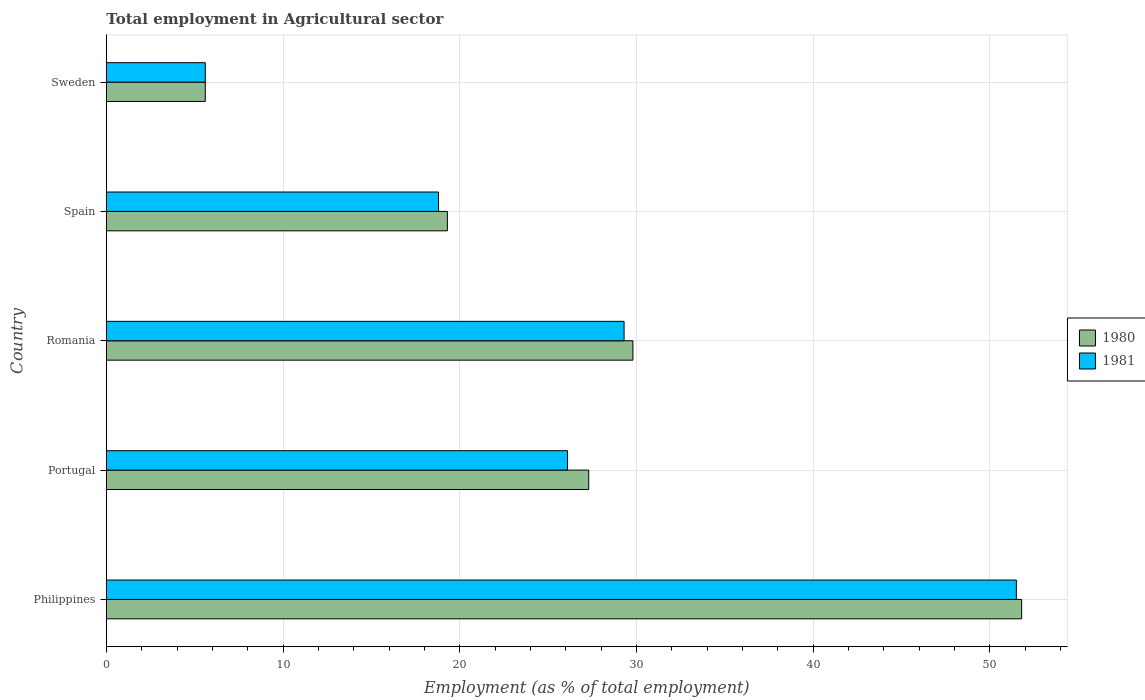Are the number of bars per tick equal to the number of legend labels?
Give a very brief answer. Yes. Are the number of bars on each tick of the Y-axis equal?
Provide a short and direct response. Yes. How many bars are there on the 4th tick from the top?
Ensure brevity in your answer.  2. What is the label of the 3rd group of bars from the top?
Give a very brief answer. Romania. In how many cases, is the number of bars for a given country not equal to the number of legend labels?
Your answer should be compact. 0. What is the employment in agricultural sector in 1980 in Sweden?
Your answer should be very brief. 5.6. Across all countries, what is the maximum employment in agricultural sector in 1981?
Give a very brief answer. 51.5. Across all countries, what is the minimum employment in agricultural sector in 1981?
Your answer should be very brief. 5.6. In which country was the employment in agricultural sector in 1981 maximum?
Provide a short and direct response. Philippines. In which country was the employment in agricultural sector in 1981 minimum?
Keep it short and to the point. Sweden. What is the total employment in agricultural sector in 1980 in the graph?
Ensure brevity in your answer.  133.8. What is the difference between the employment in agricultural sector in 1981 in Spain and that in Sweden?
Offer a very short reply. 13.2. What is the difference between the employment in agricultural sector in 1980 in Spain and the employment in agricultural sector in 1981 in Portugal?
Offer a very short reply. -6.8. What is the average employment in agricultural sector in 1981 per country?
Provide a succinct answer. 26.26. What is the difference between the employment in agricultural sector in 1980 and employment in agricultural sector in 1981 in Philippines?
Your answer should be compact. 0.3. In how many countries, is the employment in agricultural sector in 1981 greater than 34 %?
Ensure brevity in your answer.  1. What is the ratio of the employment in agricultural sector in 1980 in Philippines to that in Sweden?
Ensure brevity in your answer.  9.25. What is the difference between the highest and the second highest employment in agricultural sector in 1980?
Offer a very short reply. 22. What is the difference between the highest and the lowest employment in agricultural sector in 1980?
Your answer should be compact. 46.2. Is the sum of the employment in agricultural sector in 1981 in Romania and Sweden greater than the maximum employment in agricultural sector in 1980 across all countries?
Offer a very short reply. No. How many bars are there?
Provide a short and direct response. 10. How many countries are there in the graph?
Make the answer very short. 5. Does the graph contain grids?
Give a very brief answer. Yes. How are the legend labels stacked?
Keep it short and to the point. Vertical. What is the title of the graph?
Offer a terse response. Total employment in Agricultural sector. What is the label or title of the X-axis?
Make the answer very short. Employment (as % of total employment). What is the label or title of the Y-axis?
Your response must be concise. Country. What is the Employment (as % of total employment) of 1980 in Philippines?
Keep it short and to the point. 51.8. What is the Employment (as % of total employment) of 1981 in Philippines?
Make the answer very short. 51.5. What is the Employment (as % of total employment) in 1980 in Portugal?
Give a very brief answer. 27.3. What is the Employment (as % of total employment) in 1981 in Portugal?
Your answer should be compact. 26.1. What is the Employment (as % of total employment) of 1980 in Romania?
Your answer should be compact. 29.8. What is the Employment (as % of total employment) of 1981 in Romania?
Ensure brevity in your answer.  29.3. What is the Employment (as % of total employment) of 1980 in Spain?
Provide a succinct answer. 19.3. What is the Employment (as % of total employment) in 1981 in Spain?
Ensure brevity in your answer.  18.8. What is the Employment (as % of total employment) of 1980 in Sweden?
Provide a short and direct response. 5.6. What is the Employment (as % of total employment) of 1981 in Sweden?
Provide a succinct answer. 5.6. Across all countries, what is the maximum Employment (as % of total employment) in 1980?
Make the answer very short. 51.8. Across all countries, what is the maximum Employment (as % of total employment) of 1981?
Your answer should be compact. 51.5. Across all countries, what is the minimum Employment (as % of total employment) of 1980?
Give a very brief answer. 5.6. Across all countries, what is the minimum Employment (as % of total employment) of 1981?
Provide a short and direct response. 5.6. What is the total Employment (as % of total employment) of 1980 in the graph?
Ensure brevity in your answer.  133.8. What is the total Employment (as % of total employment) of 1981 in the graph?
Offer a very short reply. 131.3. What is the difference between the Employment (as % of total employment) of 1980 in Philippines and that in Portugal?
Offer a very short reply. 24.5. What is the difference between the Employment (as % of total employment) in 1981 in Philippines and that in Portugal?
Your answer should be compact. 25.4. What is the difference between the Employment (as % of total employment) of 1980 in Philippines and that in Romania?
Make the answer very short. 22. What is the difference between the Employment (as % of total employment) in 1981 in Philippines and that in Romania?
Provide a succinct answer. 22.2. What is the difference between the Employment (as % of total employment) of 1980 in Philippines and that in Spain?
Make the answer very short. 32.5. What is the difference between the Employment (as % of total employment) of 1981 in Philippines and that in Spain?
Provide a short and direct response. 32.7. What is the difference between the Employment (as % of total employment) of 1980 in Philippines and that in Sweden?
Your response must be concise. 46.2. What is the difference between the Employment (as % of total employment) of 1981 in Philippines and that in Sweden?
Your answer should be compact. 45.9. What is the difference between the Employment (as % of total employment) of 1980 in Portugal and that in Romania?
Make the answer very short. -2.5. What is the difference between the Employment (as % of total employment) in 1980 in Portugal and that in Spain?
Your answer should be compact. 8. What is the difference between the Employment (as % of total employment) in 1980 in Portugal and that in Sweden?
Provide a succinct answer. 21.7. What is the difference between the Employment (as % of total employment) of 1981 in Portugal and that in Sweden?
Ensure brevity in your answer.  20.5. What is the difference between the Employment (as % of total employment) of 1981 in Romania and that in Spain?
Ensure brevity in your answer.  10.5. What is the difference between the Employment (as % of total employment) in 1980 in Romania and that in Sweden?
Your answer should be compact. 24.2. What is the difference between the Employment (as % of total employment) of 1981 in Romania and that in Sweden?
Ensure brevity in your answer.  23.7. What is the difference between the Employment (as % of total employment) in 1981 in Spain and that in Sweden?
Offer a very short reply. 13.2. What is the difference between the Employment (as % of total employment) in 1980 in Philippines and the Employment (as % of total employment) in 1981 in Portugal?
Offer a terse response. 25.7. What is the difference between the Employment (as % of total employment) of 1980 in Philippines and the Employment (as % of total employment) of 1981 in Romania?
Offer a very short reply. 22.5. What is the difference between the Employment (as % of total employment) of 1980 in Philippines and the Employment (as % of total employment) of 1981 in Spain?
Give a very brief answer. 33. What is the difference between the Employment (as % of total employment) in 1980 in Philippines and the Employment (as % of total employment) in 1981 in Sweden?
Give a very brief answer. 46.2. What is the difference between the Employment (as % of total employment) of 1980 in Portugal and the Employment (as % of total employment) of 1981 in Spain?
Ensure brevity in your answer.  8.5. What is the difference between the Employment (as % of total employment) in 1980 in Portugal and the Employment (as % of total employment) in 1981 in Sweden?
Ensure brevity in your answer.  21.7. What is the difference between the Employment (as % of total employment) of 1980 in Romania and the Employment (as % of total employment) of 1981 in Spain?
Your response must be concise. 11. What is the difference between the Employment (as % of total employment) in 1980 in Romania and the Employment (as % of total employment) in 1981 in Sweden?
Provide a short and direct response. 24.2. What is the average Employment (as % of total employment) of 1980 per country?
Offer a terse response. 26.76. What is the average Employment (as % of total employment) of 1981 per country?
Your answer should be very brief. 26.26. What is the difference between the Employment (as % of total employment) of 1980 and Employment (as % of total employment) of 1981 in Romania?
Provide a succinct answer. 0.5. What is the difference between the Employment (as % of total employment) in 1980 and Employment (as % of total employment) in 1981 in Sweden?
Offer a terse response. 0. What is the ratio of the Employment (as % of total employment) of 1980 in Philippines to that in Portugal?
Make the answer very short. 1.9. What is the ratio of the Employment (as % of total employment) in 1981 in Philippines to that in Portugal?
Your answer should be very brief. 1.97. What is the ratio of the Employment (as % of total employment) in 1980 in Philippines to that in Romania?
Provide a succinct answer. 1.74. What is the ratio of the Employment (as % of total employment) in 1981 in Philippines to that in Romania?
Provide a succinct answer. 1.76. What is the ratio of the Employment (as % of total employment) of 1980 in Philippines to that in Spain?
Provide a succinct answer. 2.68. What is the ratio of the Employment (as % of total employment) of 1981 in Philippines to that in Spain?
Provide a short and direct response. 2.74. What is the ratio of the Employment (as % of total employment) of 1980 in Philippines to that in Sweden?
Offer a terse response. 9.25. What is the ratio of the Employment (as % of total employment) in 1981 in Philippines to that in Sweden?
Provide a short and direct response. 9.2. What is the ratio of the Employment (as % of total employment) in 1980 in Portugal to that in Romania?
Keep it short and to the point. 0.92. What is the ratio of the Employment (as % of total employment) of 1981 in Portugal to that in Romania?
Provide a succinct answer. 0.89. What is the ratio of the Employment (as % of total employment) of 1980 in Portugal to that in Spain?
Your answer should be compact. 1.41. What is the ratio of the Employment (as % of total employment) of 1981 in Portugal to that in Spain?
Make the answer very short. 1.39. What is the ratio of the Employment (as % of total employment) in 1980 in Portugal to that in Sweden?
Give a very brief answer. 4.88. What is the ratio of the Employment (as % of total employment) of 1981 in Portugal to that in Sweden?
Provide a short and direct response. 4.66. What is the ratio of the Employment (as % of total employment) in 1980 in Romania to that in Spain?
Offer a very short reply. 1.54. What is the ratio of the Employment (as % of total employment) of 1981 in Romania to that in Spain?
Provide a short and direct response. 1.56. What is the ratio of the Employment (as % of total employment) of 1980 in Romania to that in Sweden?
Keep it short and to the point. 5.32. What is the ratio of the Employment (as % of total employment) of 1981 in Romania to that in Sweden?
Keep it short and to the point. 5.23. What is the ratio of the Employment (as % of total employment) in 1980 in Spain to that in Sweden?
Offer a very short reply. 3.45. What is the ratio of the Employment (as % of total employment) in 1981 in Spain to that in Sweden?
Your response must be concise. 3.36. What is the difference between the highest and the lowest Employment (as % of total employment) of 1980?
Your answer should be very brief. 46.2. What is the difference between the highest and the lowest Employment (as % of total employment) in 1981?
Your answer should be very brief. 45.9. 